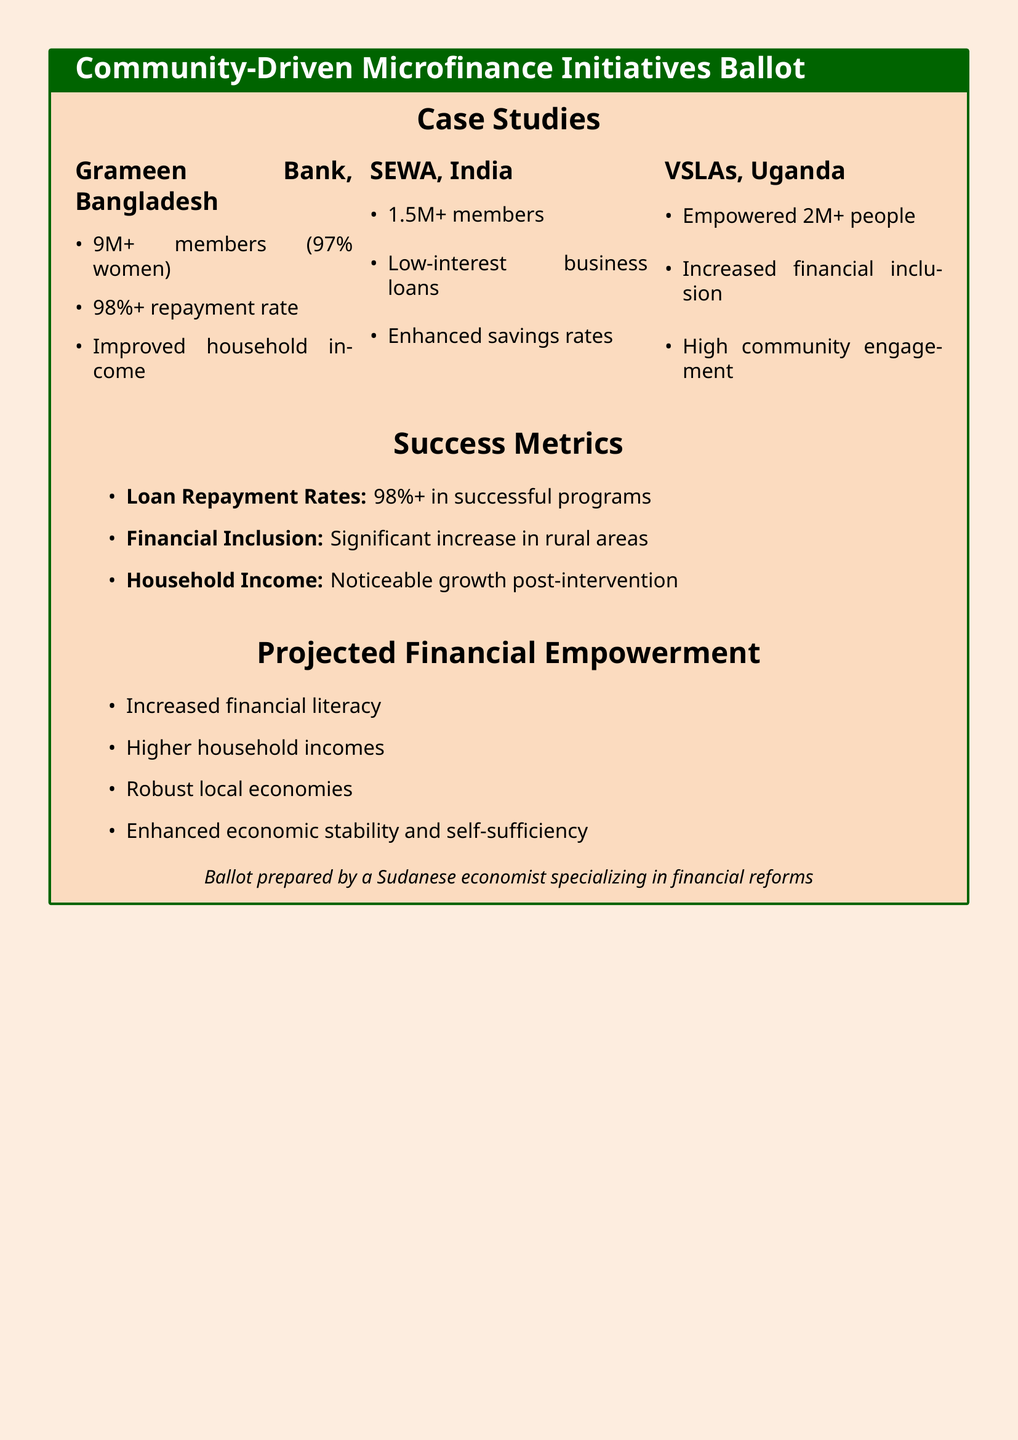What is the repayment rate for Grameen Bank? The repayment rate for Grameen Bank is mentioned as over 98%.
Answer: 98%+ How many members does SEWA have? The document states that SEWA has over 1.5 million members.
Answer: 1.5M+ What percentage of Grameen Bank members are women? The document indicates that 97% of Grameen Bank members are women.
Answer: 97% How many people have been empowered by VSLAs in Uganda? The document mentions that VSLAs have empowered over 2 million people.
Answer: 2M+ What is one of the projected outcomes of financial empowerment? The document lists several outcomes, including increased financial literacy.
Answer: Increased financial literacy What are the success metrics associated with microfinance initiatives? The document highlights several success metrics, including loan repayment rates and household income growth.
Answer: Loan Repayment Rates, Financial Inclusion, Household Income Which country is associated with the Grameen Bank initiative? The document specifies that the Grameen Bank is based in Bangladesh.
Answer: Bangladesh What is a common feature of the case studies mentioned? The case studies highlight high levels of community engagement and improved financial inclusion.
Answer: High community engagement What type of loans does SEWA provide? The document mentions that SEWA provides low-interest business loans.
Answer: Low-interest business loans 